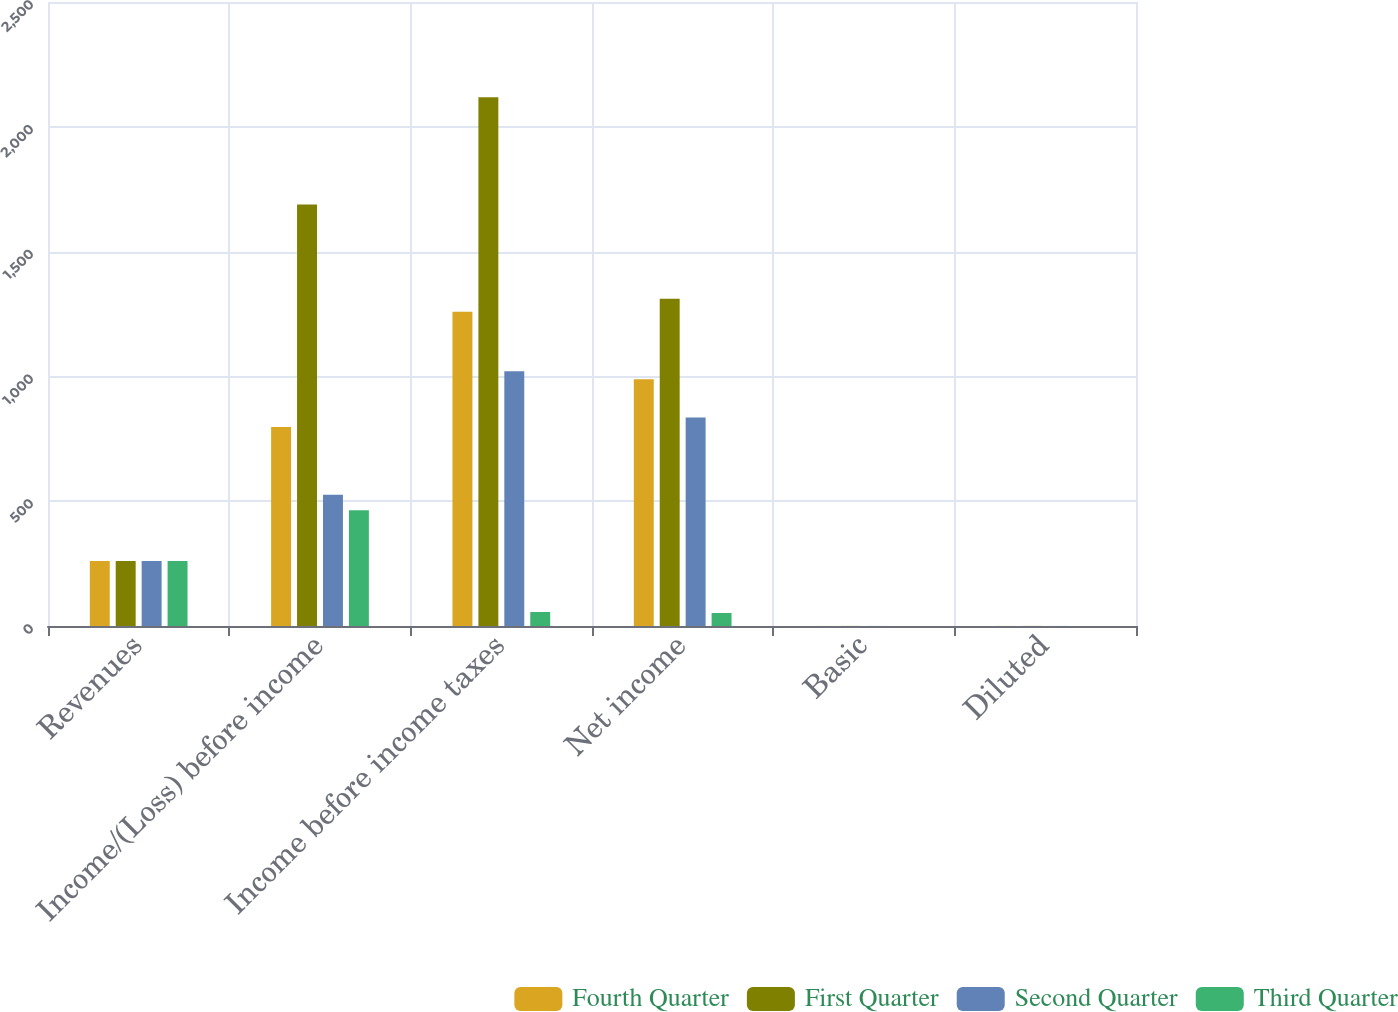Convert chart to OTSL. <chart><loc_0><loc_0><loc_500><loc_500><stacked_bar_chart><ecel><fcel>Revenues<fcel>Income/(Loss) before income<fcel>Income before income taxes<fcel>Net income<fcel>Basic<fcel>Diluted<nl><fcel>Fourth Quarter<fcel>260<fcel>797<fcel>1259<fcel>989<fcel>0.25<fcel>0.24<nl><fcel>First Quarter<fcel>260<fcel>1689<fcel>2118<fcel>1311<fcel>0.33<fcel>0.32<nl><fcel>Second Quarter<fcel>260<fcel>526<fcel>1021<fcel>835<fcel>0.22<fcel>0.21<nl><fcel>Third Quarter<fcel>260<fcel>464<fcel>56<fcel>52<fcel>0.01<fcel>0.01<nl></chart> 